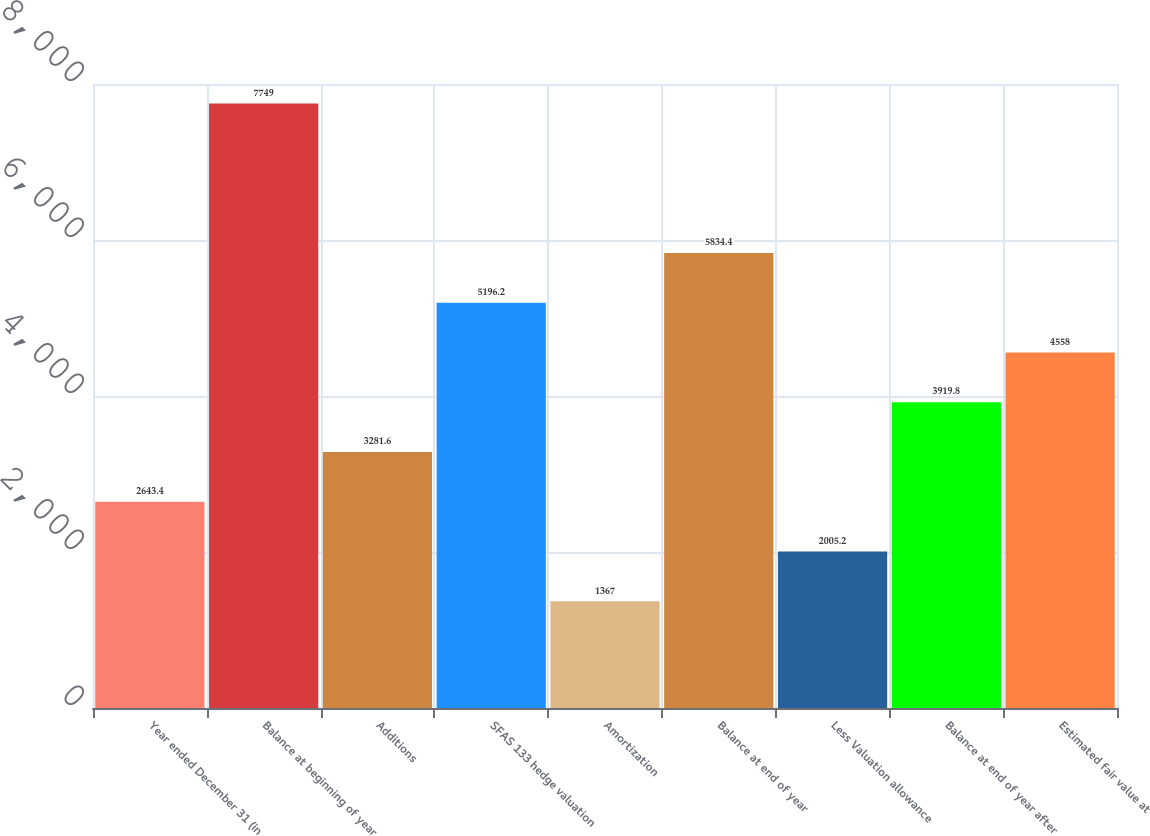Convert chart. <chart><loc_0><loc_0><loc_500><loc_500><bar_chart><fcel>Year ended December 31 (in<fcel>Balance at beginning of year<fcel>Additions<fcel>SFAS 133 hedge valuation<fcel>Amortization<fcel>Balance at end of year<fcel>Less Valuation allowance<fcel>Balance at end of year after<fcel>Estimated fair value at<nl><fcel>2643.4<fcel>7749<fcel>3281.6<fcel>5196.2<fcel>1367<fcel>5834.4<fcel>2005.2<fcel>3919.8<fcel>4558<nl></chart> 